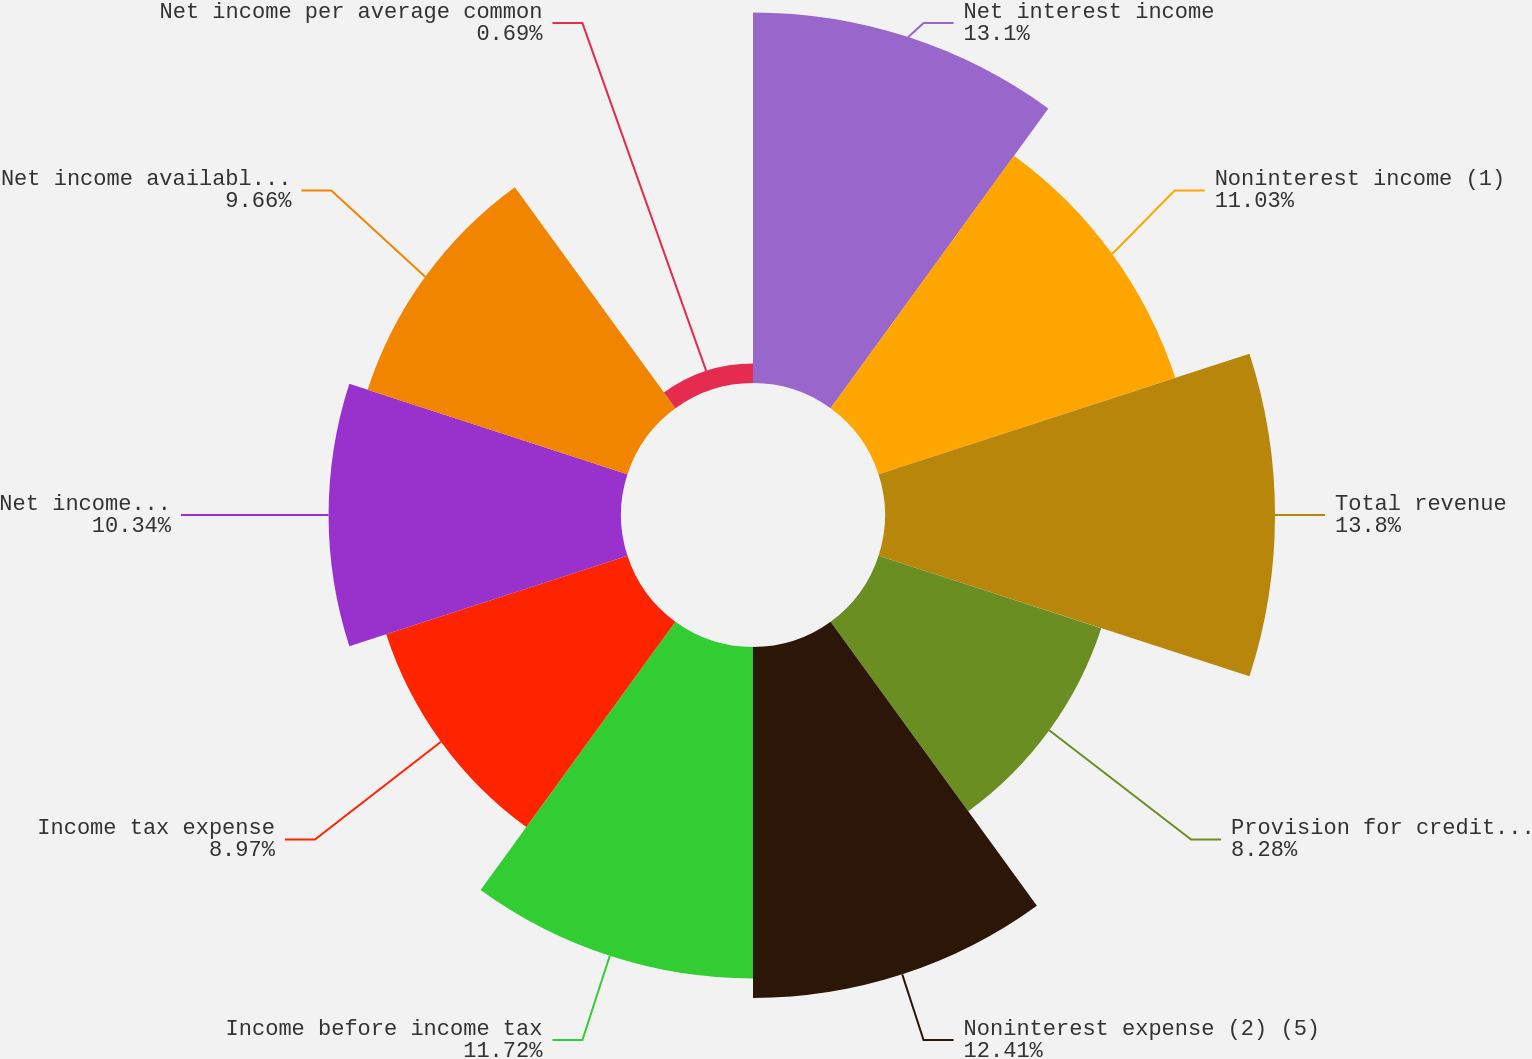Convert chart. <chart><loc_0><loc_0><loc_500><loc_500><pie_chart><fcel>Net interest income<fcel>Noninterest income (1)<fcel>Total revenue<fcel>Provision for credit losses<fcel>Noninterest expense (2) (5)<fcel>Income before income tax<fcel>Income tax expense<fcel>Net income (3) (6) (9)<fcel>Net income available to common<fcel>Net income per average common<nl><fcel>13.1%<fcel>11.03%<fcel>13.79%<fcel>8.28%<fcel>12.41%<fcel>11.72%<fcel>8.97%<fcel>10.34%<fcel>9.66%<fcel>0.69%<nl></chart> 